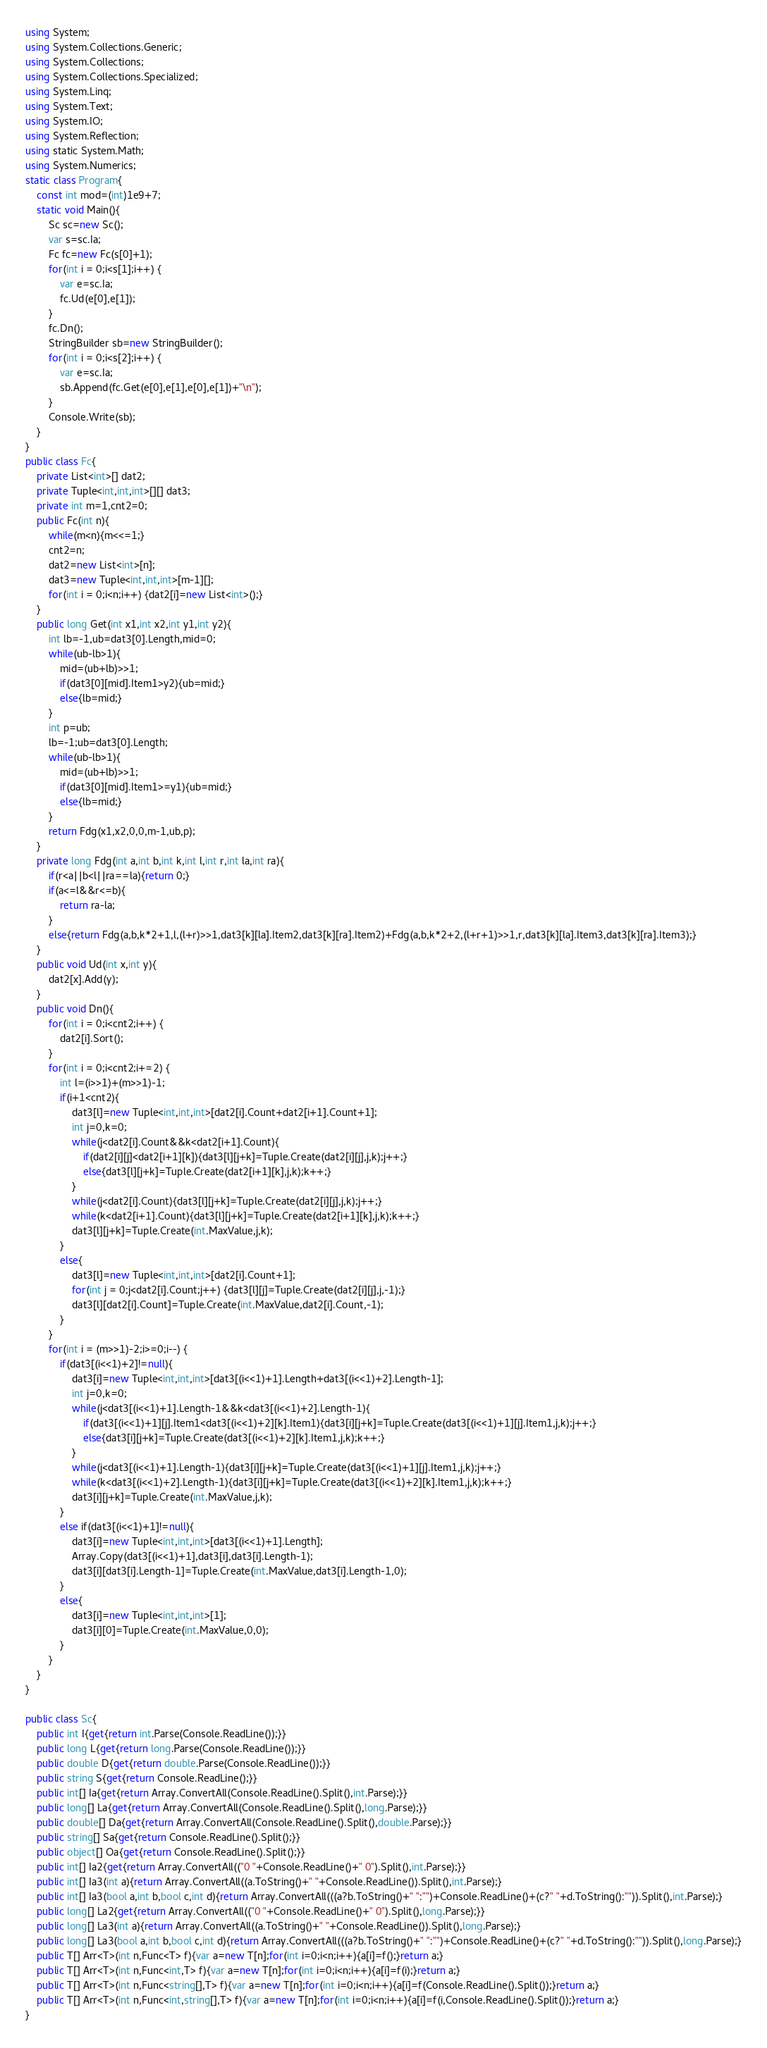<code> <loc_0><loc_0><loc_500><loc_500><_C#_>using System;
using System.Collections.Generic;
using System.Collections;
using System.Collections.Specialized;
using System.Linq;
using System.Text;
using System.IO;
using System.Reflection;
using static System.Math;
using System.Numerics;
static class Program{
	const int mod=(int)1e9+7;
	static void Main(){
		Sc sc=new Sc();
		var s=sc.Ia;
		Fc fc=new Fc(s[0]+1);
		for(int i = 0;i<s[1];i++) {
			var e=sc.Ia;
			fc.Ud(e[0],e[1]);
		}
		fc.Dn();
		StringBuilder sb=new StringBuilder();
		for(int i = 0;i<s[2];i++) {
			var e=sc.Ia;
			sb.Append(fc.Get(e[0],e[1],e[0],e[1])+"\n");
		}
		Console.Write(sb);
	}
}
public class Fc{
	private List<int>[] dat2;
	private Tuple<int,int,int>[][] dat3;
	private int m=1,cnt2=0;
	public Fc(int n){
		while(m<n){m<<=1;}
		cnt2=n;
		dat2=new List<int>[n];
		dat3=new Tuple<int,int,int>[m-1][];
		for(int i = 0;i<n;i++) {dat2[i]=new List<int>();}
	}
	public long Get(int x1,int x2,int y1,int y2){
		int lb=-1,ub=dat3[0].Length,mid=0;
		while(ub-lb>1){
			mid=(ub+lb)>>1;
			if(dat3[0][mid].Item1>y2){ub=mid;}
			else{lb=mid;}
		}
		int p=ub;
		lb=-1;ub=dat3[0].Length;
		while(ub-lb>1){
			mid=(ub+lb)>>1;
			if(dat3[0][mid].Item1>=y1){ub=mid;}
			else{lb=mid;}
		}
		return Fdg(x1,x2,0,0,m-1,ub,p);
	}
	private long Fdg(int a,int b,int k,int l,int r,int la,int ra){
		if(r<a||b<l||ra==la){return 0;}
		if(a<=l&&r<=b){
			return ra-la;
		}
		else{return Fdg(a,b,k*2+1,l,(l+r)>>1,dat3[k][la].Item2,dat3[k][ra].Item2)+Fdg(a,b,k*2+2,(l+r+1)>>1,r,dat3[k][la].Item3,dat3[k][ra].Item3);}
	}
	public void Ud(int x,int y){
		dat2[x].Add(y);
	}
	public void Dn(){
		for(int i = 0;i<cnt2;i++) {
			dat2[i].Sort();
		}
		for(int i = 0;i<cnt2;i+=2) {
			int l=(i>>1)+(m>>1)-1;
			if(i+1<cnt2){
				dat3[l]=new Tuple<int,int,int>[dat2[i].Count+dat2[i+1].Count+1];
				int j=0,k=0;
				while(j<dat2[i].Count&&k<dat2[i+1].Count){
					if(dat2[i][j]<dat2[i+1][k]){dat3[l][j+k]=Tuple.Create(dat2[i][j],j,k);j++;}
					else{dat3[l][j+k]=Tuple.Create(dat2[i+1][k],j,k);k++;}
				}
				while(j<dat2[i].Count){dat3[l][j+k]=Tuple.Create(dat2[i][j],j,k);j++;}
				while(k<dat2[i+1].Count){dat3[l][j+k]=Tuple.Create(dat2[i+1][k],j,k);k++;}
				dat3[l][j+k]=Tuple.Create(int.MaxValue,j,k);
			}
			else{
				dat3[l]=new Tuple<int,int,int>[dat2[i].Count+1];
				for(int j = 0;j<dat2[i].Count;j++) {dat3[l][j]=Tuple.Create(dat2[i][j],j,-1);}
				dat3[l][dat2[i].Count]=Tuple.Create(int.MaxValue,dat2[i].Count,-1);
			}
		}
		for(int i = (m>>1)-2;i>=0;i--) {
			if(dat3[(i<<1)+2]!=null){
				dat3[i]=new Tuple<int,int,int>[dat3[(i<<1)+1].Length+dat3[(i<<1)+2].Length-1];
				int j=0,k=0;
				while(j<dat3[(i<<1)+1].Length-1&&k<dat3[(i<<1)+2].Length-1){
					if(dat3[(i<<1)+1][j].Item1<dat3[(i<<1)+2][k].Item1){dat3[i][j+k]=Tuple.Create(dat3[(i<<1)+1][j].Item1,j,k);j++;}
					else{dat3[i][j+k]=Tuple.Create(dat3[(i<<1)+2][k].Item1,j,k);k++;}
				}
				while(j<dat3[(i<<1)+1].Length-1){dat3[i][j+k]=Tuple.Create(dat3[(i<<1)+1][j].Item1,j,k);j++;}
				while(k<dat3[(i<<1)+2].Length-1){dat3[i][j+k]=Tuple.Create(dat3[(i<<1)+2][k].Item1,j,k);k++;}
				dat3[i][j+k]=Tuple.Create(int.MaxValue,j,k);
			}
			else if(dat3[(i<<1)+1]!=null){
				dat3[i]=new Tuple<int,int,int>[dat3[(i<<1)+1].Length];
				Array.Copy(dat3[(i<<1)+1],dat3[i],dat3[i].Length-1);
				dat3[i][dat3[i].Length-1]=Tuple.Create(int.MaxValue,dat3[i].Length-1,0);
			}
			else{
				dat3[i]=new Tuple<int,int,int>[1];
				dat3[i][0]=Tuple.Create(int.MaxValue,0,0);
			}
		}
	}
}

public class Sc{
	public int I{get{return int.Parse(Console.ReadLine());}}
	public long L{get{return long.Parse(Console.ReadLine());}}
	public double D{get{return double.Parse(Console.ReadLine());}}
	public string S{get{return Console.ReadLine();}}
	public int[] Ia{get{return Array.ConvertAll(Console.ReadLine().Split(),int.Parse);}}
	public long[] La{get{return Array.ConvertAll(Console.ReadLine().Split(),long.Parse);}}
	public double[] Da{get{return Array.ConvertAll(Console.ReadLine().Split(),double.Parse);}}
	public string[] Sa{get{return Console.ReadLine().Split();}}
	public object[] Oa{get{return Console.ReadLine().Split();}}
	public int[] Ia2{get{return Array.ConvertAll(("0 "+Console.ReadLine()+" 0").Split(),int.Parse);}}
	public int[] Ia3(int a){return Array.ConvertAll((a.ToString()+" "+Console.ReadLine()).Split(),int.Parse);}
	public int[] Ia3(bool a,int b,bool c,int d){return Array.ConvertAll(((a?b.ToString()+" ":"")+Console.ReadLine()+(c?" "+d.ToString():"")).Split(),int.Parse);}
	public long[] La2{get{return Array.ConvertAll(("0 "+Console.ReadLine()+" 0").Split(),long.Parse);}}
	public long[] La3(int a){return Array.ConvertAll((a.ToString()+" "+Console.ReadLine()).Split(),long.Parse);}
	public long[] La3(bool a,int b,bool c,int d){return Array.ConvertAll(((a?b.ToString()+" ":"")+Console.ReadLine()+(c?" "+d.ToString():"")).Split(),long.Parse);}
	public T[] Arr<T>(int n,Func<T> f){var a=new T[n];for(int i=0;i<n;i++){a[i]=f();}return a;}
	public T[] Arr<T>(int n,Func<int,T> f){var a=new T[n];for(int i=0;i<n;i++){a[i]=f(i);}return a;}
	public T[] Arr<T>(int n,Func<string[],T> f){var a=new T[n];for(int i=0;i<n;i++){a[i]=f(Console.ReadLine().Split());}return a;}
	public T[] Arr<T>(int n,Func<int,string[],T> f){var a=new T[n];for(int i=0;i<n;i++){a[i]=f(i,Console.ReadLine().Split());}return a;}
}</code> 